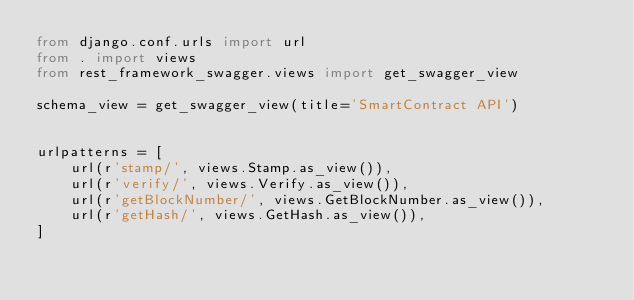Convert code to text. <code><loc_0><loc_0><loc_500><loc_500><_Python_>from django.conf.urls import url
from . import views
from rest_framework_swagger.views import get_swagger_view

schema_view = get_swagger_view(title='SmartContract API')


urlpatterns = [
    url(r'stamp/', views.Stamp.as_view()),
    url(r'verify/', views.Verify.as_view()),
    url(r'getBlockNumber/', views.GetBlockNumber.as_view()),
    url(r'getHash/', views.GetHash.as_view()),
]
</code> 